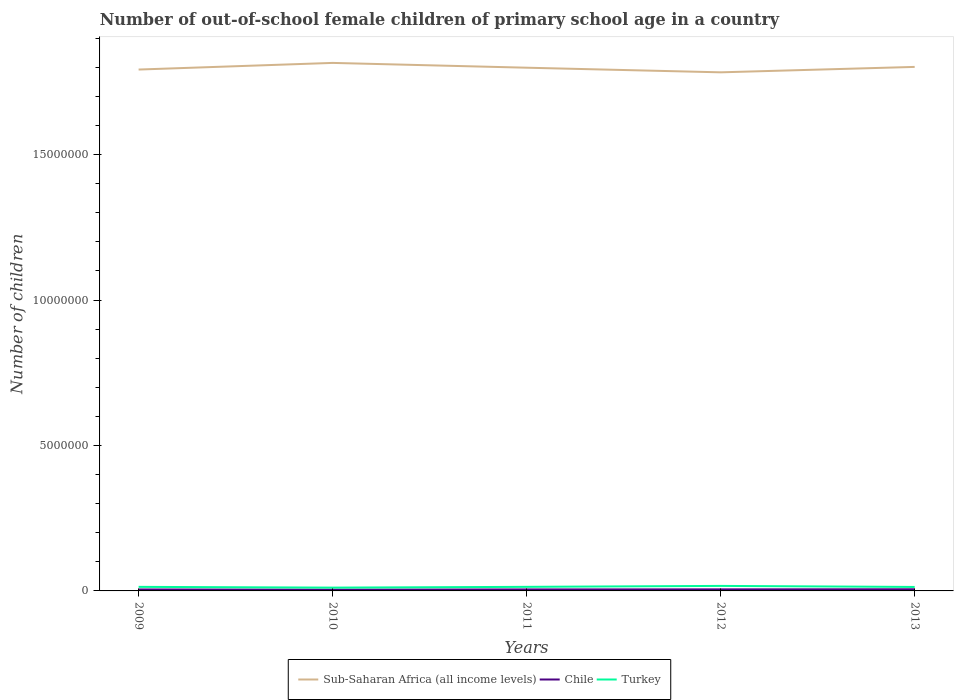Does the line corresponding to Chile intersect with the line corresponding to Turkey?
Your answer should be very brief. No. Is the number of lines equal to the number of legend labels?
Keep it short and to the point. Yes. Across all years, what is the maximum number of out-of-school female children in Sub-Saharan Africa (all income levels)?
Your answer should be very brief. 1.78e+07. In which year was the number of out-of-school female children in Chile maximum?
Make the answer very short. 2010. What is the total number of out-of-school female children in Turkey in the graph?
Your answer should be compact. -3.27e+04. What is the difference between the highest and the second highest number of out-of-school female children in Sub-Saharan Africa (all income levels)?
Ensure brevity in your answer.  3.24e+05. How many years are there in the graph?
Give a very brief answer. 5. Are the values on the major ticks of Y-axis written in scientific E-notation?
Your answer should be compact. No. Where does the legend appear in the graph?
Make the answer very short. Bottom center. How many legend labels are there?
Your answer should be very brief. 3. How are the legend labels stacked?
Offer a very short reply. Horizontal. What is the title of the graph?
Make the answer very short. Number of out-of-school female children of primary school age in a country. Does "Australia" appear as one of the legend labels in the graph?
Give a very brief answer. No. What is the label or title of the Y-axis?
Your response must be concise. Number of children. What is the Number of children of Sub-Saharan Africa (all income levels) in 2009?
Offer a very short reply. 1.79e+07. What is the Number of children in Chile in 2009?
Offer a terse response. 5.01e+04. What is the Number of children of Turkey in 2009?
Provide a succinct answer. 1.40e+05. What is the Number of children of Sub-Saharan Africa (all income levels) in 2010?
Your answer should be very brief. 1.82e+07. What is the Number of children in Chile in 2010?
Keep it short and to the point. 4.36e+04. What is the Number of children of Turkey in 2010?
Ensure brevity in your answer.  1.13e+05. What is the Number of children in Sub-Saharan Africa (all income levels) in 2011?
Offer a terse response. 1.80e+07. What is the Number of children of Chile in 2011?
Provide a succinct answer. 5.12e+04. What is the Number of children of Turkey in 2011?
Offer a terse response. 1.40e+05. What is the Number of children in Sub-Saharan Africa (all income levels) in 2012?
Make the answer very short. 1.78e+07. What is the Number of children of Chile in 2012?
Provide a succinct answer. 5.35e+04. What is the Number of children of Turkey in 2012?
Keep it short and to the point. 1.72e+05. What is the Number of children of Sub-Saharan Africa (all income levels) in 2013?
Keep it short and to the point. 1.80e+07. What is the Number of children of Chile in 2013?
Ensure brevity in your answer.  5.71e+04. What is the Number of children of Turkey in 2013?
Your response must be concise. 1.36e+05. Across all years, what is the maximum Number of children in Sub-Saharan Africa (all income levels)?
Your answer should be compact. 1.82e+07. Across all years, what is the maximum Number of children in Chile?
Offer a very short reply. 5.71e+04. Across all years, what is the maximum Number of children of Turkey?
Your answer should be very brief. 1.72e+05. Across all years, what is the minimum Number of children of Sub-Saharan Africa (all income levels)?
Provide a succinct answer. 1.78e+07. Across all years, what is the minimum Number of children in Chile?
Your response must be concise. 4.36e+04. Across all years, what is the minimum Number of children of Turkey?
Give a very brief answer. 1.13e+05. What is the total Number of children of Sub-Saharan Africa (all income levels) in the graph?
Provide a short and direct response. 8.99e+07. What is the total Number of children in Chile in the graph?
Your answer should be very brief. 2.55e+05. What is the total Number of children in Turkey in the graph?
Provide a short and direct response. 7.01e+05. What is the difference between the Number of children of Sub-Saharan Africa (all income levels) in 2009 and that in 2010?
Your answer should be compact. -2.28e+05. What is the difference between the Number of children of Chile in 2009 and that in 2010?
Offer a very short reply. 6443. What is the difference between the Number of children of Turkey in 2009 and that in 2010?
Your response must be concise. 2.61e+04. What is the difference between the Number of children of Sub-Saharan Africa (all income levels) in 2009 and that in 2011?
Offer a very short reply. -6.33e+04. What is the difference between the Number of children in Chile in 2009 and that in 2011?
Offer a very short reply. -1152. What is the difference between the Number of children of Turkey in 2009 and that in 2011?
Your answer should be compact. -429. What is the difference between the Number of children in Sub-Saharan Africa (all income levels) in 2009 and that in 2012?
Make the answer very short. 9.59e+04. What is the difference between the Number of children of Chile in 2009 and that in 2012?
Provide a succinct answer. -3376. What is the difference between the Number of children of Turkey in 2009 and that in 2012?
Your answer should be very brief. -3.27e+04. What is the difference between the Number of children of Sub-Saharan Africa (all income levels) in 2009 and that in 2013?
Give a very brief answer. -9.09e+04. What is the difference between the Number of children in Chile in 2009 and that in 2013?
Offer a terse response. -7035. What is the difference between the Number of children in Turkey in 2009 and that in 2013?
Your answer should be compact. 3100. What is the difference between the Number of children in Sub-Saharan Africa (all income levels) in 2010 and that in 2011?
Your response must be concise. 1.65e+05. What is the difference between the Number of children of Chile in 2010 and that in 2011?
Provide a succinct answer. -7595. What is the difference between the Number of children of Turkey in 2010 and that in 2011?
Offer a very short reply. -2.66e+04. What is the difference between the Number of children in Sub-Saharan Africa (all income levels) in 2010 and that in 2012?
Your answer should be compact. 3.24e+05. What is the difference between the Number of children in Chile in 2010 and that in 2012?
Provide a short and direct response. -9819. What is the difference between the Number of children in Turkey in 2010 and that in 2012?
Your response must be concise. -5.88e+04. What is the difference between the Number of children of Sub-Saharan Africa (all income levels) in 2010 and that in 2013?
Offer a terse response. 1.37e+05. What is the difference between the Number of children in Chile in 2010 and that in 2013?
Provide a short and direct response. -1.35e+04. What is the difference between the Number of children in Turkey in 2010 and that in 2013?
Make the answer very short. -2.30e+04. What is the difference between the Number of children in Sub-Saharan Africa (all income levels) in 2011 and that in 2012?
Your response must be concise. 1.59e+05. What is the difference between the Number of children of Chile in 2011 and that in 2012?
Offer a very short reply. -2224. What is the difference between the Number of children of Turkey in 2011 and that in 2012?
Your response must be concise. -3.23e+04. What is the difference between the Number of children of Sub-Saharan Africa (all income levels) in 2011 and that in 2013?
Provide a short and direct response. -2.76e+04. What is the difference between the Number of children in Chile in 2011 and that in 2013?
Your answer should be very brief. -5883. What is the difference between the Number of children of Turkey in 2011 and that in 2013?
Make the answer very short. 3529. What is the difference between the Number of children in Sub-Saharan Africa (all income levels) in 2012 and that in 2013?
Your response must be concise. -1.87e+05. What is the difference between the Number of children of Chile in 2012 and that in 2013?
Your answer should be compact. -3659. What is the difference between the Number of children in Turkey in 2012 and that in 2013?
Keep it short and to the point. 3.58e+04. What is the difference between the Number of children of Sub-Saharan Africa (all income levels) in 2009 and the Number of children of Chile in 2010?
Ensure brevity in your answer.  1.79e+07. What is the difference between the Number of children of Sub-Saharan Africa (all income levels) in 2009 and the Number of children of Turkey in 2010?
Ensure brevity in your answer.  1.78e+07. What is the difference between the Number of children in Chile in 2009 and the Number of children in Turkey in 2010?
Your response must be concise. -6.33e+04. What is the difference between the Number of children of Sub-Saharan Africa (all income levels) in 2009 and the Number of children of Chile in 2011?
Ensure brevity in your answer.  1.79e+07. What is the difference between the Number of children of Sub-Saharan Africa (all income levels) in 2009 and the Number of children of Turkey in 2011?
Your response must be concise. 1.78e+07. What is the difference between the Number of children in Chile in 2009 and the Number of children in Turkey in 2011?
Give a very brief answer. -8.99e+04. What is the difference between the Number of children of Sub-Saharan Africa (all income levels) in 2009 and the Number of children of Chile in 2012?
Make the answer very short. 1.79e+07. What is the difference between the Number of children of Sub-Saharan Africa (all income levels) in 2009 and the Number of children of Turkey in 2012?
Offer a terse response. 1.78e+07. What is the difference between the Number of children of Chile in 2009 and the Number of children of Turkey in 2012?
Make the answer very short. -1.22e+05. What is the difference between the Number of children in Sub-Saharan Africa (all income levels) in 2009 and the Number of children in Chile in 2013?
Your answer should be very brief. 1.79e+07. What is the difference between the Number of children of Sub-Saharan Africa (all income levels) in 2009 and the Number of children of Turkey in 2013?
Provide a succinct answer. 1.78e+07. What is the difference between the Number of children in Chile in 2009 and the Number of children in Turkey in 2013?
Keep it short and to the point. -8.63e+04. What is the difference between the Number of children in Sub-Saharan Africa (all income levels) in 2010 and the Number of children in Chile in 2011?
Your answer should be compact. 1.81e+07. What is the difference between the Number of children in Sub-Saharan Africa (all income levels) in 2010 and the Number of children in Turkey in 2011?
Offer a terse response. 1.80e+07. What is the difference between the Number of children of Chile in 2010 and the Number of children of Turkey in 2011?
Provide a short and direct response. -9.63e+04. What is the difference between the Number of children of Sub-Saharan Africa (all income levels) in 2010 and the Number of children of Chile in 2012?
Your answer should be compact. 1.81e+07. What is the difference between the Number of children of Sub-Saharan Africa (all income levels) in 2010 and the Number of children of Turkey in 2012?
Provide a succinct answer. 1.80e+07. What is the difference between the Number of children in Chile in 2010 and the Number of children in Turkey in 2012?
Provide a short and direct response. -1.29e+05. What is the difference between the Number of children of Sub-Saharan Africa (all income levels) in 2010 and the Number of children of Chile in 2013?
Ensure brevity in your answer.  1.81e+07. What is the difference between the Number of children in Sub-Saharan Africa (all income levels) in 2010 and the Number of children in Turkey in 2013?
Provide a succinct answer. 1.80e+07. What is the difference between the Number of children of Chile in 2010 and the Number of children of Turkey in 2013?
Offer a very short reply. -9.28e+04. What is the difference between the Number of children of Sub-Saharan Africa (all income levels) in 2011 and the Number of children of Chile in 2012?
Your answer should be very brief. 1.79e+07. What is the difference between the Number of children in Sub-Saharan Africa (all income levels) in 2011 and the Number of children in Turkey in 2012?
Keep it short and to the point. 1.78e+07. What is the difference between the Number of children in Chile in 2011 and the Number of children in Turkey in 2012?
Give a very brief answer. -1.21e+05. What is the difference between the Number of children in Sub-Saharan Africa (all income levels) in 2011 and the Number of children in Chile in 2013?
Your response must be concise. 1.79e+07. What is the difference between the Number of children of Sub-Saharan Africa (all income levels) in 2011 and the Number of children of Turkey in 2013?
Your answer should be very brief. 1.79e+07. What is the difference between the Number of children of Chile in 2011 and the Number of children of Turkey in 2013?
Your answer should be compact. -8.52e+04. What is the difference between the Number of children in Sub-Saharan Africa (all income levels) in 2012 and the Number of children in Chile in 2013?
Your answer should be compact. 1.78e+07. What is the difference between the Number of children of Sub-Saharan Africa (all income levels) in 2012 and the Number of children of Turkey in 2013?
Offer a very short reply. 1.77e+07. What is the difference between the Number of children of Chile in 2012 and the Number of children of Turkey in 2013?
Ensure brevity in your answer.  -8.30e+04. What is the average Number of children of Sub-Saharan Africa (all income levels) per year?
Make the answer very short. 1.80e+07. What is the average Number of children in Chile per year?
Provide a succinct answer. 5.11e+04. What is the average Number of children of Turkey per year?
Offer a terse response. 1.40e+05. In the year 2009, what is the difference between the Number of children of Sub-Saharan Africa (all income levels) and Number of children of Chile?
Your response must be concise. 1.79e+07. In the year 2009, what is the difference between the Number of children of Sub-Saharan Africa (all income levels) and Number of children of Turkey?
Offer a very short reply. 1.78e+07. In the year 2009, what is the difference between the Number of children in Chile and Number of children in Turkey?
Your answer should be very brief. -8.94e+04. In the year 2010, what is the difference between the Number of children of Sub-Saharan Africa (all income levels) and Number of children of Chile?
Offer a very short reply. 1.81e+07. In the year 2010, what is the difference between the Number of children in Sub-Saharan Africa (all income levels) and Number of children in Turkey?
Your response must be concise. 1.80e+07. In the year 2010, what is the difference between the Number of children in Chile and Number of children in Turkey?
Ensure brevity in your answer.  -6.97e+04. In the year 2011, what is the difference between the Number of children in Sub-Saharan Africa (all income levels) and Number of children in Chile?
Provide a short and direct response. 1.79e+07. In the year 2011, what is the difference between the Number of children of Sub-Saharan Africa (all income levels) and Number of children of Turkey?
Give a very brief answer. 1.78e+07. In the year 2011, what is the difference between the Number of children in Chile and Number of children in Turkey?
Offer a terse response. -8.87e+04. In the year 2012, what is the difference between the Number of children in Sub-Saharan Africa (all income levels) and Number of children in Chile?
Offer a very short reply. 1.78e+07. In the year 2012, what is the difference between the Number of children in Sub-Saharan Africa (all income levels) and Number of children in Turkey?
Give a very brief answer. 1.77e+07. In the year 2012, what is the difference between the Number of children of Chile and Number of children of Turkey?
Offer a terse response. -1.19e+05. In the year 2013, what is the difference between the Number of children of Sub-Saharan Africa (all income levels) and Number of children of Chile?
Provide a succinct answer. 1.80e+07. In the year 2013, what is the difference between the Number of children of Sub-Saharan Africa (all income levels) and Number of children of Turkey?
Provide a short and direct response. 1.79e+07. In the year 2013, what is the difference between the Number of children of Chile and Number of children of Turkey?
Your response must be concise. -7.93e+04. What is the ratio of the Number of children in Sub-Saharan Africa (all income levels) in 2009 to that in 2010?
Offer a very short reply. 0.99. What is the ratio of the Number of children in Chile in 2009 to that in 2010?
Provide a short and direct response. 1.15. What is the ratio of the Number of children in Turkey in 2009 to that in 2010?
Provide a short and direct response. 1.23. What is the ratio of the Number of children in Chile in 2009 to that in 2011?
Your answer should be compact. 0.98. What is the ratio of the Number of children of Turkey in 2009 to that in 2011?
Your response must be concise. 1. What is the ratio of the Number of children in Sub-Saharan Africa (all income levels) in 2009 to that in 2012?
Ensure brevity in your answer.  1.01. What is the ratio of the Number of children in Chile in 2009 to that in 2012?
Ensure brevity in your answer.  0.94. What is the ratio of the Number of children in Turkey in 2009 to that in 2012?
Keep it short and to the point. 0.81. What is the ratio of the Number of children in Sub-Saharan Africa (all income levels) in 2009 to that in 2013?
Ensure brevity in your answer.  0.99. What is the ratio of the Number of children of Chile in 2009 to that in 2013?
Give a very brief answer. 0.88. What is the ratio of the Number of children in Turkey in 2009 to that in 2013?
Keep it short and to the point. 1.02. What is the ratio of the Number of children of Sub-Saharan Africa (all income levels) in 2010 to that in 2011?
Keep it short and to the point. 1.01. What is the ratio of the Number of children in Chile in 2010 to that in 2011?
Your answer should be compact. 0.85. What is the ratio of the Number of children in Turkey in 2010 to that in 2011?
Your answer should be very brief. 0.81. What is the ratio of the Number of children in Sub-Saharan Africa (all income levels) in 2010 to that in 2012?
Your answer should be very brief. 1.02. What is the ratio of the Number of children in Chile in 2010 to that in 2012?
Your answer should be compact. 0.82. What is the ratio of the Number of children of Turkey in 2010 to that in 2012?
Provide a short and direct response. 0.66. What is the ratio of the Number of children in Sub-Saharan Africa (all income levels) in 2010 to that in 2013?
Provide a succinct answer. 1.01. What is the ratio of the Number of children of Chile in 2010 to that in 2013?
Give a very brief answer. 0.76. What is the ratio of the Number of children in Turkey in 2010 to that in 2013?
Your answer should be very brief. 0.83. What is the ratio of the Number of children of Sub-Saharan Africa (all income levels) in 2011 to that in 2012?
Provide a short and direct response. 1.01. What is the ratio of the Number of children of Chile in 2011 to that in 2012?
Your response must be concise. 0.96. What is the ratio of the Number of children in Turkey in 2011 to that in 2012?
Make the answer very short. 0.81. What is the ratio of the Number of children in Sub-Saharan Africa (all income levels) in 2011 to that in 2013?
Keep it short and to the point. 1. What is the ratio of the Number of children in Chile in 2011 to that in 2013?
Your answer should be compact. 0.9. What is the ratio of the Number of children in Turkey in 2011 to that in 2013?
Provide a succinct answer. 1.03. What is the ratio of the Number of children of Sub-Saharan Africa (all income levels) in 2012 to that in 2013?
Your answer should be compact. 0.99. What is the ratio of the Number of children of Chile in 2012 to that in 2013?
Your response must be concise. 0.94. What is the ratio of the Number of children of Turkey in 2012 to that in 2013?
Your answer should be compact. 1.26. What is the difference between the highest and the second highest Number of children in Sub-Saharan Africa (all income levels)?
Your answer should be compact. 1.37e+05. What is the difference between the highest and the second highest Number of children of Chile?
Your response must be concise. 3659. What is the difference between the highest and the second highest Number of children of Turkey?
Provide a short and direct response. 3.23e+04. What is the difference between the highest and the lowest Number of children of Sub-Saharan Africa (all income levels)?
Offer a very short reply. 3.24e+05. What is the difference between the highest and the lowest Number of children of Chile?
Your answer should be very brief. 1.35e+04. What is the difference between the highest and the lowest Number of children in Turkey?
Make the answer very short. 5.88e+04. 